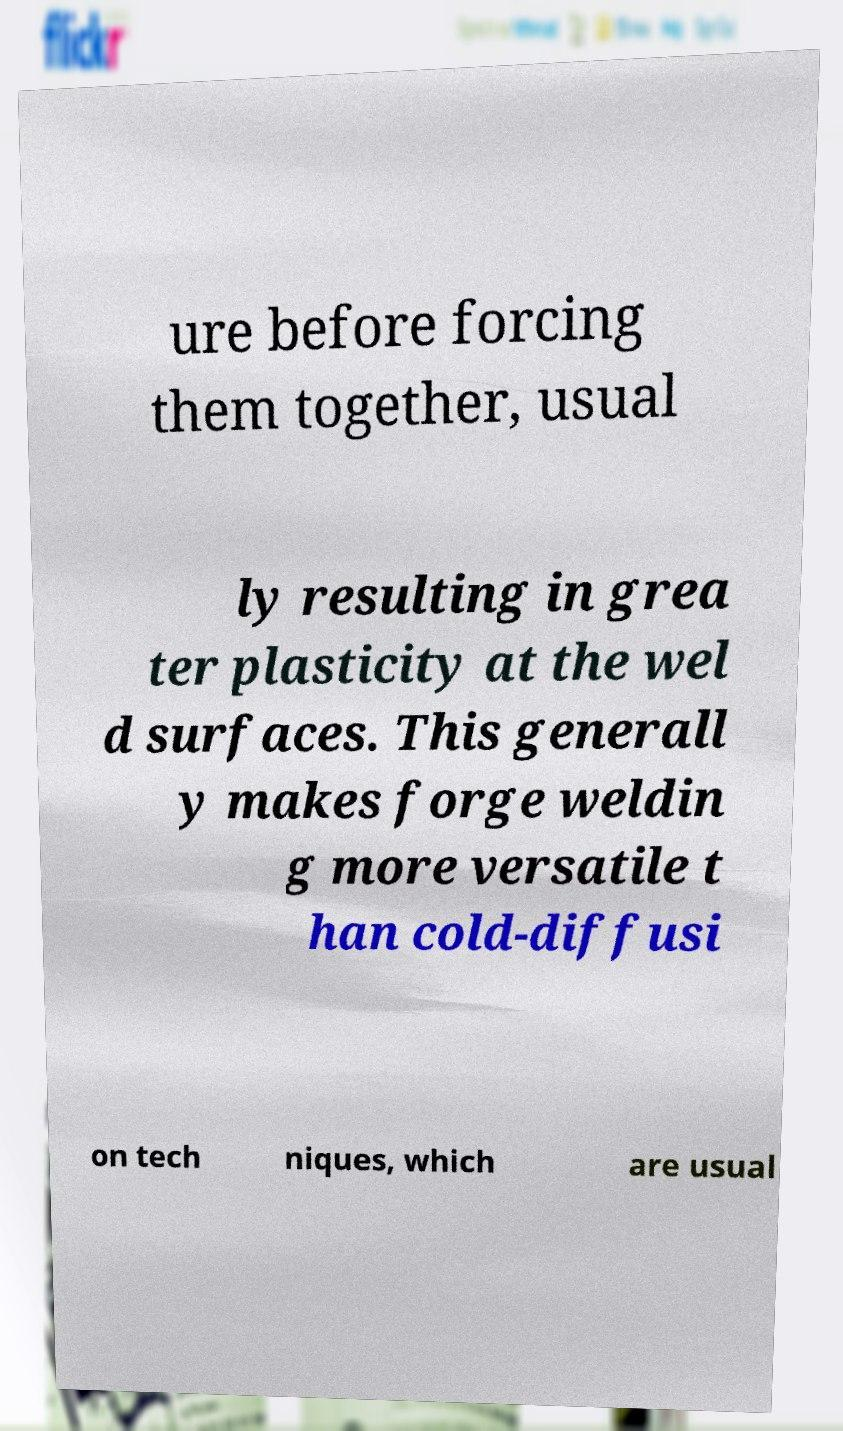Can you read and provide the text displayed in the image?This photo seems to have some interesting text. Can you extract and type it out for me? ure before forcing them together, usual ly resulting in grea ter plasticity at the wel d surfaces. This generall y makes forge weldin g more versatile t han cold-diffusi on tech niques, which are usual 